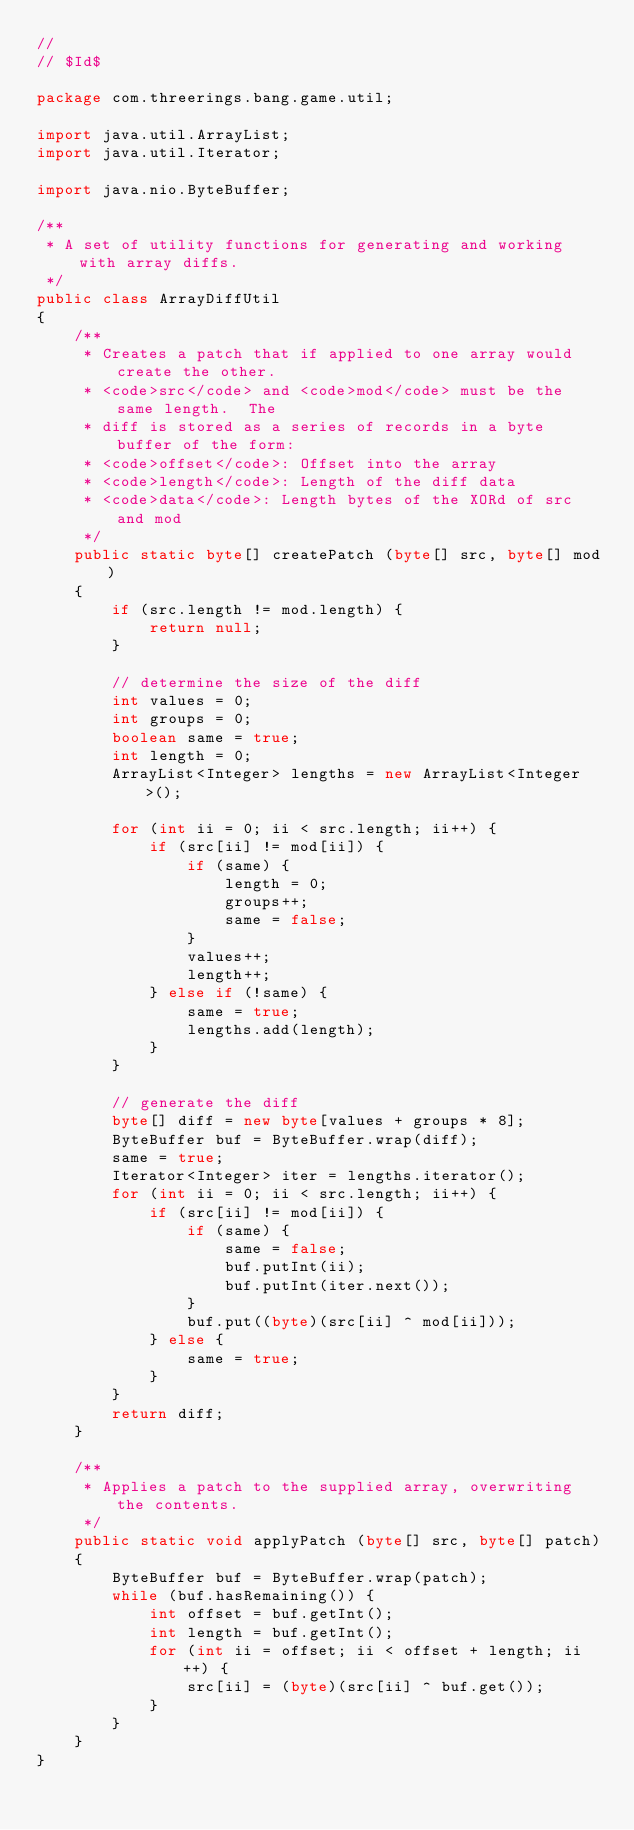Convert code to text. <code><loc_0><loc_0><loc_500><loc_500><_Java_>//
// $Id$

package com.threerings.bang.game.util;

import java.util.ArrayList;
import java.util.Iterator;

import java.nio.ByteBuffer;

/**
 * A set of utility functions for generating and working with array diffs.
 */
public class ArrayDiffUtil
{
    /**
     * Creates a patch that if applied to one array would create the other.
     * <code>src</code> and <code>mod</code> must be the same length.  The
     * diff is stored as a series of records in a byte buffer of the form:
     * <code>offset</code>: Offset into the array
     * <code>length</code>: Length of the diff data
     * <code>data</code>: Length bytes of the XORd of src and mod
     */
    public static byte[] createPatch (byte[] src, byte[] mod)
    {
        if (src.length != mod.length) {
            return null;
        }
        
        // determine the size of the diff
        int values = 0;
        int groups = 0;
        boolean same = true;
        int length = 0;
        ArrayList<Integer> lengths = new ArrayList<Integer>();

        for (int ii = 0; ii < src.length; ii++) {
            if (src[ii] != mod[ii]) {
                if (same) {
                    length = 0;
                    groups++;
                    same = false;
                }
                values++;
                length++;
            } else if (!same) {
                same = true;
                lengths.add(length);
            }
        }

        // generate the diff
        byte[] diff = new byte[values + groups * 8];
        ByteBuffer buf = ByteBuffer.wrap(diff);
        same = true;
        Iterator<Integer> iter = lengths.iterator();
        for (int ii = 0; ii < src.length; ii++) {
            if (src[ii] != mod[ii]) {
                if (same) {
                    same = false;
                    buf.putInt(ii);
                    buf.putInt(iter.next());
                }
                buf.put((byte)(src[ii] ^ mod[ii]));
            } else {
                same = true;
            }
        }
        return diff;    
    }

    /**
     * Applies a patch to the supplied array, overwriting the contents.
     */
    public static void applyPatch (byte[] src, byte[] patch)
    {
        ByteBuffer buf = ByteBuffer.wrap(patch);
        while (buf.hasRemaining()) {
            int offset = buf.getInt();
            int length = buf.getInt();
            for (int ii = offset; ii < offset + length; ii++) {
                src[ii] = (byte)(src[ii] ^ buf.get());
            }
        }
    }
}
</code> 